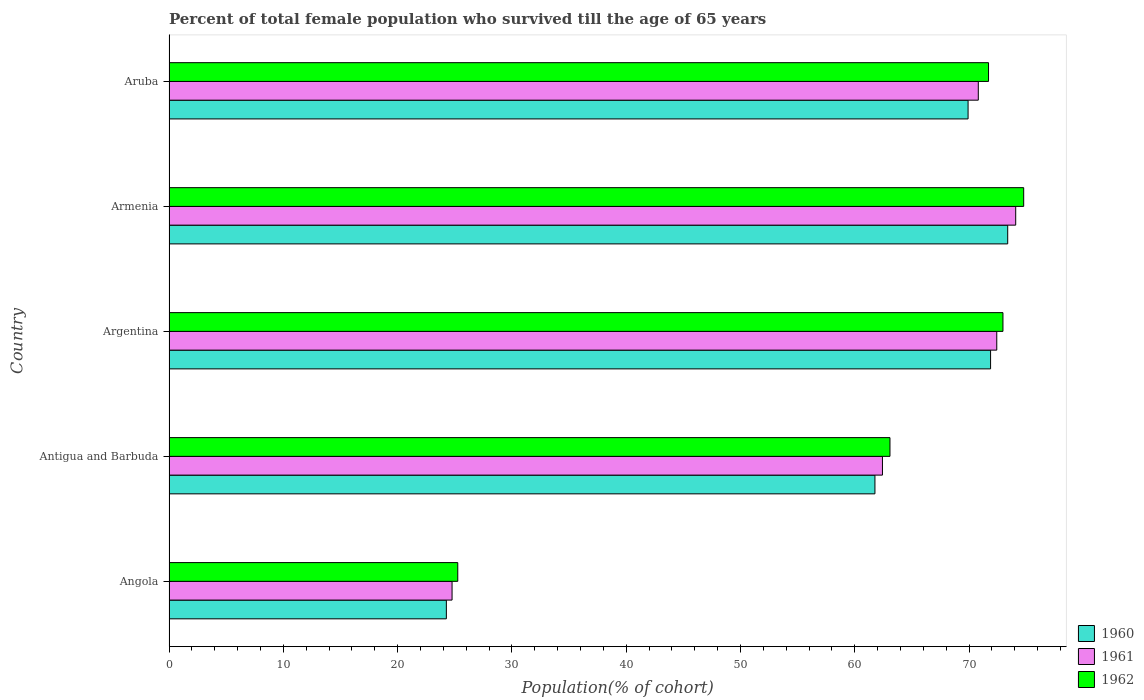How many different coloured bars are there?
Ensure brevity in your answer.  3. Are the number of bars on each tick of the Y-axis equal?
Your answer should be compact. Yes. How many bars are there on the 5th tick from the bottom?
Make the answer very short. 3. What is the label of the 5th group of bars from the top?
Provide a succinct answer. Angola. What is the percentage of total female population who survived till the age of 65 years in 1960 in Angola?
Provide a succinct answer. 24.27. Across all countries, what is the maximum percentage of total female population who survived till the age of 65 years in 1961?
Make the answer very short. 74.08. Across all countries, what is the minimum percentage of total female population who survived till the age of 65 years in 1962?
Ensure brevity in your answer.  25.27. In which country was the percentage of total female population who survived till the age of 65 years in 1961 maximum?
Give a very brief answer. Armenia. In which country was the percentage of total female population who survived till the age of 65 years in 1962 minimum?
Provide a succinct answer. Angola. What is the total percentage of total female population who survived till the age of 65 years in 1962 in the graph?
Your answer should be very brief. 307.8. What is the difference between the percentage of total female population who survived till the age of 65 years in 1960 in Angola and that in Antigua and Barbuda?
Make the answer very short. -37.5. What is the difference between the percentage of total female population who survived till the age of 65 years in 1960 in Antigua and Barbuda and the percentage of total female population who survived till the age of 65 years in 1961 in Aruba?
Offer a very short reply. -9.04. What is the average percentage of total female population who survived till the age of 65 years in 1960 per country?
Keep it short and to the point. 60.24. What is the difference between the percentage of total female population who survived till the age of 65 years in 1962 and percentage of total female population who survived till the age of 65 years in 1960 in Angola?
Keep it short and to the point. 1. In how many countries, is the percentage of total female population who survived till the age of 65 years in 1962 greater than 42 %?
Make the answer very short. 4. What is the ratio of the percentage of total female population who survived till the age of 65 years in 1960 in Angola to that in Argentina?
Offer a terse response. 0.34. Is the difference between the percentage of total female population who survived till the age of 65 years in 1962 in Argentina and Aruba greater than the difference between the percentage of total female population who survived till the age of 65 years in 1960 in Argentina and Aruba?
Offer a very short reply. No. What is the difference between the highest and the second highest percentage of total female population who survived till the age of 65 years in 1962?
Make the answer very short. 1.82. What is the difference between the highest and the lowest percentage of total female population who survived till the age of 65 years in 1962?
Provide a short and direct response. 49.52. In how many countries, is the percentage of total female population who survived till the age of 65 years in 1961 greater than the average percentage of total female population who survived till the age of 65 years in 1961 taken over all countries?
Offer a terse response. 4. Is the sum of the percentage of total female population who survived till the age of 65 years in 1962 in Antigua and Barbuda and Aruba greater than the maximum percentage of total female population who survived till the age of 65 years in 1961 across all countries?
Your answer should be very brief. Yes. Is it the case that in every country, the sum of the percentage of total female population who survived till the age of 65 years in 1961 and percentage of total female population who survived till the age of 65 years in 1962 is greater than the percentage of total female population who survived till the age of 65 years in 1960?
Ensure brevity in your answer.  Yes. How many countries are there in the graph?
Your answer should be compact. 5. What is the difference between two consecutive major ticks on the X-axis?
Offer a very short reply. 10. Does the graph contain any zero values?
Your answer should be very brief. No. Does the graph contain grids?
Keep it short and to the point. No. How many legend labels are there?
Make the answer very short. 3. What is the title of the graph?
Your response must be concise. Percent of total female population who survived till the age of 65 years. What is the label or title of the X-axis?
Make the answer very short. Population(% of cohort). What is the Population(% of cohort) in 1960 in Angola?
Offer a very short reply. 24.27. What is the Population(% of cohort) of 1961 in Angola?
Ensure brevity in your answer.  24.77. What is the Population(% of cohort) of 1962 in Angola?
Ensure brevity in your answer.  25.27. What is the Population(% of cohort) in 1960 in Antigua and Barbuda?
Give a very brief answer. 61.77. What is the Population(% of cohort) of 1961 in Antigua and Barbuda?
Provide a succinct answer. 62.42. What is the Population(% of cohort) of 1962 in Antigua and Barbuda?
Your response must be concise. 63.08. What is the Population(% of cohort) in 1960 in Argentina?
Provide a short and direct response. 71.88. What is the Population(% of cohort) of 1961 in Argentina?
Keep it short and to the point. 72.43. What is the Population(% of cohort) in 1962 in Argentina?
Offer a terse response. 72.97. What is the Population(% of cohort) of 1960 in Armenia?
Your answer should be compact. 73.38. What is the Population(% of cohort) of 1961 in Armenia?
Offer a very short reply. 74.08. What is the Population(% of cohort) in 1962 in Armenia?
Offer a terse response. 74.78. What is the Population(% of cohort) of 1960 in Aruba?
Your answer should be compact. 69.92. What is the Population(% of cohort) in 1961 in Aruba?
Give a very brief answer. 70.81. What is the Population(% of cohort) in 1962 in Aruba?
Your answer should be very brief. 71.71. Across all countries, what is the maximum Population(% of cohort) of 1960?
Make the answer very short. 73.38. Across all countries, what is the maximum Population(% of cohort) in 1961?
Make the answer very short. 74.08. Across all countries, what is the maximum Population(% of cohort) in 1962?
Your answer should be compact. 74.78. Across all countries, what is the minimum Population(% of cohort) in 1960?
Offer a very short reply. 24.27. Across all countries, what is the minimum Population(% of cohort) in 1961?
Ensure brevity in your answer.  24.77. Across all countries, what is the minimum Population(% of cohort) in 1962?
Your answer should be very brief. 25.27. What is the total Population(% of cohort) in 1960 in the graph?
Give a very brief answer. 301.22. What is the total Population(% of cohort) in 1961 in the graph?
Provide a succinct answer. 304.51. What is the total Population(% of cohort) of 1962 in the graph?
Your response must be concise. 307.8. What is the difference between the Population(% of cohort) of 1960 in Angola and that in Antigua and Barbuda?
Your answer should be compact. -37.5. What is the difference between the Population(% of cohort) of 1961 in Angola and that in Antigua and Barbuda?
Your answer should be very brief. -37.66. What is the difference between the Population(% of cohort) of 1962 in Angola and that in Antigua and Barbuda?
Your answer should be very brief. -37.82. What is the difference between the Population(% of cohort) of 1960 in Angola and that in Argentina?
Give a very brief answer. -47.62. What is the difference between the Population(% of cohort) of 1961 in Angola and that in Argentina?
Offer a terse response. -47.66. What is the difference between the Population(% of cohort) of 1962 in Angola and that in Argentina?
Make the answer very short. -47.7. What is the difference between the Population(% of cohort) of 1960 in Angola and that in Armenia?
Your response must be concise. -49.12. What is the difference between the Population(% of cohort) in 1961 in Angola and that in Armenia?
Your answer should be compact. -49.32. What is the difference between the Population(% of cohort) of 1962 in Angola and that in Armenia?
Your answer should be very brief. -49.52. What is the difference between the Population(% of cohort) in 1960 in Angola and that in Aruba?
Your answer should be compact. -45.65. What is the difference between the Population(% of cohort) of 1961 in Angola and that in Aruba?
Give a very brief answer. -46.04. What is the difference between the Population(% of cohort) of 1962 in Angola and that in Aruba?
Offer a very short reply. -46.44. What is the difference between the Population(% of cohort) of 1960 in Antigua and Barbuda and that in Argentina?
Your response must be concise. -10.12. What is the difference between the Population(% of cohort) in 1961 in Antigua and Barbuda and that in Argentina?
Provide a short and direct response. -10. What is the difference between the Population(% of cohort) of 1962 in Antigua and Barbuda and that in Argentina?
Your answer should be very brief. -9.88. What is the difference between the Population(% of cohort) in 1960 in Antigua and Barbuda and that in Armenia?
Offer a very short reply. -11.62. What is the difference between the Population(% of cohort) of 1961 in Antigua and Barbuda and that in Armenia?
Offer a very short reply. -11.66. What is the difference between the Population(% of cohort) in 1962 in Antigua and Barbuda and that in Armenia?
Keep it short and to the point. -11.7. What is the difference between the Population(% of cohort) in 1960 in Antigua and Barbuda and that in Aruba?
Keep it short and to the point. -8.15. What is the difference between the Population(% of cohort) of 1961 in Antigua and Barbuda and that in Aruba?
Your answer should be compact. -8.39. What is the difference between the Population(% of cohort) in 1962 in Antigua and Barbuda and that in Aruba?
Make the answer very short. -8.62. What is the difference between the Population(% of cohort) in 1960 in Argentina and that in Armenia?
Offer a very short reply. -1.5. What is the difference between the Population(% of cohort) in 1961 in Argentina and that in Armenia?
Provide a succinct answer. -1.66. What is the difference between the Population(% of cohort) in 1962 in Argentina and that in Armenia?
Offer a terse response. -1.82. What is the difference between the Population(% of cohort) of 1960 in Argentina and that in Aruba?
Offer a very short reply. 1.97. What is the difference between the Population(% of cohort) of 1961 in Argentina and that in Aruba?
Keep it short and to the point. 1.62. What is the difference between the Population(% of cohort) in 1962 in Argentina and that in Aruba?
Your answer should be very brief. 1.26. What is the difference between the Population(% of cohort) in 1960 in Armenia and that in Aruba?
Provide a succinct answer. 3.47. What is the difference between the Population(% of cohort) in 1961 in Armenia and that in Aruba?
Ensure brevity in your answer.  3.27. What is the difference between the Population(% of cohort) of 1962 in Armenia and that in Aruba?
Provide a succinct answer. 3.08. What is the difference between the Population(% of cohort) of 1960 in Angola and the Population(% of cohort) of 1961 in Antigua and Barbuda?
Keep it short and to the point. -38.16. What is the difference between the Population(% of cohort) of 1960 in Angola and the Population(% of cohort) of 1962 in Antigua and Barbuda?
Offer a terse response. -38.82. What is the difference between the Population(% of cohort) in 1961 in Angola and the Population(% of cohort) in 1962 in Antigua and Barbuda?
Your response must be concise. -38.32. What is the difference between the Population(% of cohort) in 1960 in Angola and the Population(% of cohort) in 1961 in Argentina?
Ensure brevity in your answer.  -48.16. What is the difference between the Population(% of cohort) of 1960 in Angola and the Population(% of cohort) of 1962 in Argentina?
Offer a terse response. -48.7. What is the difference between the Population(% of cohort) in 1961 in Angola and the Population(% of cohort) in 1962 in Argentina?
Make the answer very short. -48.2. What is the difference between the Population(% of cohort) of 1960 in Angola and the Population(% of cohort) of 1961 in Armenia?
Make the answer very short. -49.82. What is the difference between the Population(% of cohort) in 1960 in Angola and the Population(% of cohort) in 1962 in Armenia?
Give a very brief answer. -50.52. What is the difference between the Population(% of cohort) of 1961 in Angola and the Population(% of cohort) of 1962 in Armenia?
Keep it short and to the point. -50.02. What is the difference between the Population(% of cohort) in 1960 in Angola and the Population(% of cohort) in 1961 in Aruba?
Provide a short and direct response. -46.54. What is the difference between the Population(% of cohort) of 1960 in Angola and the Population(% of cohort) of 1962 in Aruba?
Your answer should be compact. -47.44. What is the difference between the Population(% of cohort) in 1961 in Angola and the Population(% of cohort) in 1962 in Aruba?
Make the answer very short. -46.94. What is the difference between the Population(% of cohort) of 1960 in Antigua and Barbuda and the Population(% of cohort) of 1961 in Argentina?
Your answer should be compact. -10.66. What is the difference between the Population(% of cohort) of 1960 in Antigua and Barbuda and the Population(% of cohort) of 1962 in Argentina?
Keep it short and to the point. -11.2. What is the difference between the Population(% of cohort) in 1961 in Antigua and Barbuda and the Population(% of cohort) in 1962 in Argentina?
Keep it short and to the point. -10.54. What is the difference between the Population(% of cohort) of 1960 in Antigua and Barbuda and the Population(% of cohort) of 1961 in Armenia?
Your answer should be compact. -12.32. What is the difference between the Population(% of cohort) of 1960 in Antigua and Barbuda and the Population(% of cohort) of 1962 in Armenia?
Provide a succinct answer. -13.02. What is the difference between the Population(% of cohort) of 1961 in Antigua and Barbuda and the Population(% of cohort) of 1962 in Armenia?
Provide a succinct answer. -12.36. What is the difference between the Population(% of cohort) of 1960 in Antigua and Barbuda and the Population(% of cohort) of 1961 in Aruba?
Provide a succinct answer. -9.04. What is the difference between the Population(% of cohort) of 1960 in Antigua and Barbuda and the Population(% of cohort) of 1962 in Aruba?
Make the answer very short. -9.94. What is the difference between the Population(% of cohort) in 1961 in Antigua and Barbuda and the Population(% of cohort) in 1962 in Aruba?
Ensure brevity in your answer.  -9.28. What is the difference between the Population(% of cohort) in 1960 in Argentina and the Population(% of cohort) in 1961 in Armenia?
Your answer should be compact. -2.2. What is the difference between the Population(% of cohort) in 1960 in Argentina and the Population(% of cohort) in 1962 in Armenia?
Your answer should be very brief. -2.9. What is the difference between the Population(% of cohort) in 1961 in Argentina and the Population(% of cohort) in 1962 in Armenia?
Keep it short and to the point. -2.36. What is the difference between the Population(% of cohort) of 1960 in Argentina and the Population(% of cohort) of 1961 in Aruba?
Provide a short and direct response. 1.07. What is the difference between the Population(% of cohort) of 1960 in Argentina and the Population(% of cohort) of 1962 in Aruba?
Make the answer very short. 0.18. What is the difference between the Population(% of cohort) of 1961 in Argentina and the Population(% of cohort) of 1962 in Aruba?
Offer a terse response. 0.72. What is the difference between the Population(% of cohort) of 1960 in Armenia and the Population(% of cohort) of 1961 in Aruba?
Ensure brevity in your answer.  2.57. What is the difference between the Population(% of cohort) in 1960 in Armenia and the Population(% of cohort) in 1962 in Aruba?
Your response must be concise. 1.68. What is the difference between the Population(% of cohort) in 1961 in Armenia and the Population(% of cohort) in 1962 in Aruba?
Your answer should be compact. 2.38. What is the average Population(% of cohort) of 1960 per country?
Offer a very short reply. 60.24. What is the average Population(% of cohort) in 1961 per country?
Give a very brief answer. 60.9. What is the average Population(% of cohort) of 1962 per country?
Your answer should be very brief. 61.56. What is the difference between the Population(% of cohort) in 1960 and Population(% of cohort) in 1961 in Angola?
Offer a very short reply. -0.5. What is the difference between the Population(% of cohort) in 1960 and Population(% of cohort) in 1962 in Angola?
Your answer should be very brief. -1. What is the difference between the Population(% of cohort) in 1961 and Population(% of cohort) in 1962 in Angola?
Keep it short and to the point. -0.5. What is the difference between the Population(% of cohort) in 1960 and Population(% of cohort) in 1961 in Antigua and Barbuda?
Offer a very short reply. -0.66. What is the difference between the Population(% of cohort) in 1960 and Population(% of cohort) in 1962 in Antigua and Barbuda?
Your answer should be compact. -1.32. What is the difference between the Population(% of cohort) in 1961 and Population(% of cohort) in 1962 in Antigua and Barbuda?
Your answer should be compact. -0.66. What is the difference between the Population(% of cohort) in 1960 and Population(% of cohort) in 1961 in Argentina?
Your answer should be very brief. -0.54. What is the difference between the Population(% of cohort) of 1960 and Population(% of cohort) of 1962 in Argentina?
Provide a succinct answer. -1.08. What is the difference between the Population(% of cohort) in 1961 and Population(% of cohort) in 1962 in Argentina?
Your response must be concise. -0.54. What is the difference between the Population(% of cohort) in 1960 and Population(% of cohort) in 1961 in Armenia?
Give a very brief answer. -0.7. What is the difference between the Population(% of cohort) in 1960 and Population(% of cohort) in 1962 in Armenia?
Offer a very short reply. -1.4. What is the difference between the Population(% of cohort) of 1961 and Population(% of cohort) of 1962 in Armenia?
Offer a very short reply. -0.7. What is the difference between the Population(% of cohort) in 1960 and Population(% of cohort) in 1961 in Aruba?
Make the answer very short. -0.9. What is the difference between the Population(% of cohort) of 1960 and Population(% of cohort) of 1962 in Aruba?
Ensure brevity in your answer.  -1.79. What is the difference between the Population(% of cohort) in 1961 and Population(% of cohort) in 1962 in Aruba?
Your answer should be compact. -0.9. What is the ratio of the Population(% of cohort) in 1960 in Angola to that in Antigua and Barbuda?
Offer a terse response. 0.39. What is the ratio of the Population(% of cohort) of 1961 in Angola to that in Antigua and Barbuda?
Give a very brief answer. 0.4. What is the ratio of the Population(% of cohort) of 1962 in Angola to that in Antigua and Barbuda?
Offer a terse response. 0.4. What is the ratio of the Population(% of cohort) in 1960 in Angola to that in Argentina?
Your answer should be compact. 0.34. What is the ratio of the Population(% of cohort) in 1961 in Angola to that in Argentina?
Provide a short and direct response. 0.34. What is the ratio of the Population(% of cohort) in 1962 in Angola to that in Argentina?
Keep it short and to the point. 0.35. What is the ratio of the Population(% of cohort) in 1960 in Angola to that in Armenia?
Provide a short and direct response. 0.33. What is the ratio of the Population(% of cohort) in 1961 in Angola to that in Armenia?
Your answer should be very brief. 0.33. What is the ratio of the Population(% of cohort) of 1962 in Angola to that in Armenia?
Keep it short and to the point. 0.34. What is the ratio of the Population(% of cohort) in 1960 in Angola to that in Aruba?
Your answer should be compact. 0.35. What is the ratio of the Population(% of cohort) in 1961 in Angola to that in Aruba?
Provide a succinct answer. 0.35. What is the ratio of the Population(% of cohort) in 1962 in Angola to that in Aruba?
Offer a very short reply. 0.35. What is the ratio of the Population(% of cohort) of 1960 in Antigua and Barbuda to that in Argentina?
Your answer should be compact. 0.86. What is the ratio of the Population(% of cohort) in 1961 in Antigua and Barbuda to that in Argentina?
Your answer should be very brief. 0.86. What is the ratio of the Population(% of cohort) of 1962 in Antigua and Barbuda to that in Argentina?
Offer a terse response. 0.86. What is the ratio of the Population(% of cohort) of 1960 in Antigua and Barbuda to that in Armenia?
Offer a terse response. 0.84. What is the ratio of the Population(% of cohort) in 1961 in Antigua and Barbuda to that in Armenia?
Give a very brief answer. 0.84. What is the ratio of the Population(% of cohort) of 1962 in Antigua and Barbuda to that in Armenia?
Keep it short and to the point. 0.84. What is the ratio of the Population(% of cohort) of 1960 in Antigua and Barbuda to that in Aruba?
Offer a terse response. 0.88. What is the ratio of the Population(% of cohort) of 1961 in Antigua and Barbuda to that in Aruba?
Your answer should be very brief. 0.88. What is the ratio of the Population(% of cohort) of 1962 in Antigua and Barbuda to that in Aruba?
Keep it short and to the point. 0.88. What is the ratio of the Population(% of cohort) of 1960 in Argentina to that in Armenia?
Offer a terse response. 0.98. What is the ratio of the Population(% of cohort) in 1961 in Argentina to that in Armenia?
Your answer should be compact. 0.98. What is the ratio of the Population(% of cohort) in 1962 in Argentina to that in Armenia?
Keep it short and to the point. 0.98. What is the ratio of the Population(% of cohort) in 1960 in Argentina to that in Aruba?
Provide a short and direct response. 1.03. What is the ratio of the Population(% of cohort) of 1961 in Argentina to that in Aruba?
Offer a terse response. 1.02. What is the ratio of the Population(% of cohort) of 1962 in Argentina to that in Aruba?
Offer a very short reply. 1.02. What is the ratio of the Population(% of cohort) of 1960 in Armenia to that in Aruba?
Offer a very short reply. 1.05. What is the ratio of the Population(% of cohort) in 1961 in Armenia to that in Aruba?
Provide a short and direct response. 1.05. What is the ratio of the Population(% of cohort) of 1962 in Armenia to that in Aruba?
Ensure brevity in your answer.  1.04. What is the difference between the highest and the second highest Population(% of cohort) in 1960?
Provide a succinct answer. 1.5. What is the difference between the highest and the second highest Population(% of cohort) of 1961?
Keep it short and to the point. 1.66. What is the difference between the highest and the second highest Population(% of cohort) in 1962?
Give a very brief answer. 1.82. What is the difference between the highest and the lowest Population(% of cohort) in 1960?
Provide a succinct answer. 49.12. What is the difference between the highest and the lowest Population(% of cohort) in 1961?
Your response must be concise. 49.32. What is the difference between the highest and the lowest Population(% of cohort) in 1962?
Offer a very short reply. 49.52. 